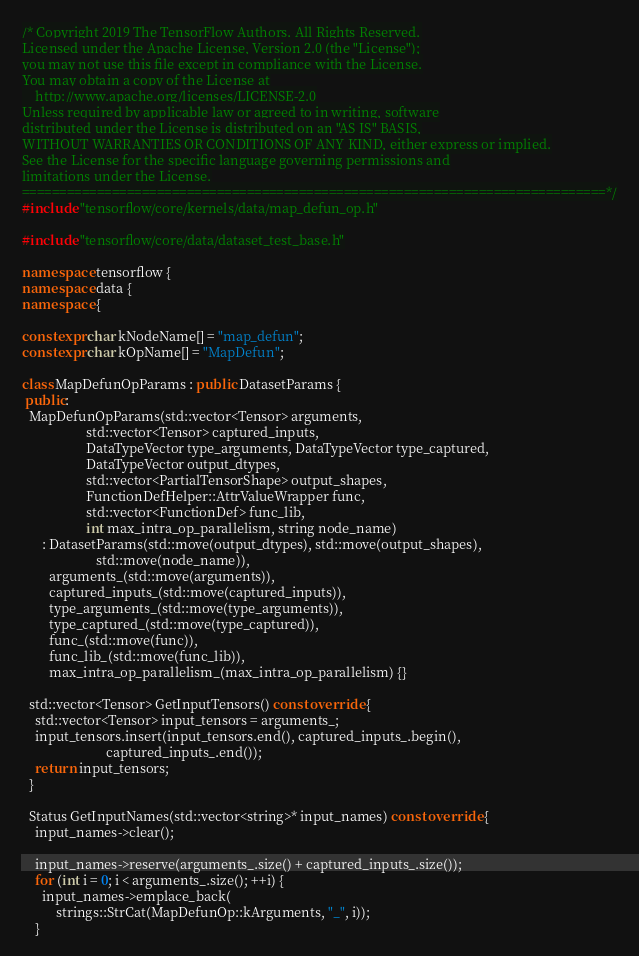Convert code to text. <code><loc_0><loc_0><loc_500><loc_500><_C++_>/* Copyright 2019 The TensorFlow Authors. All Rights Reserved.
Licensed under the Apache License, Version 2.0 (the "License");
you may not use this file except in compliance with the License.
You may obtain a copy of the License at
    http://www.apache.org/licenses/LICENSE-2.0
Unless required by applicable law or agreed to in writing, software
distributed under the License is distributed on an "AS IS" BASIS,
WITHOUT WARRANTIES OR CONDITIONS OF ANY KIND, either express or implied.
See the License for the specific language governing permissions and
limitations under the License.
==============================================================================*/
#include "tensorflow/core/kernels/data/map_defun_op.h"

#include "tensorflow/core/data/dataset_test_base.h"

namespace tensorflow {
namespace data {
namespace {

constexpr char kNodeName[] = "map_defun";
constexpr char kOpName[] = "MapDefun";

class MapDefunOpParams : public DatasetParams {
 public:
  MapDefunOpParams(std::vector<Tensor> arguments,
                   std::vector<Tensor> captured_inputs,
                   DataTypeVector type_arguments, DataTypeVector type_captured,
                   DataTypeVector output_dtypes,
                   std::vector<PartialTensorShape> output_shapes,
                   FunctionDefHelper::AttrValueWrapper func,
                   std::vector<FunctionDef> func_lib,
                   int max_intra_op_parallelism, string node_name)
      : DatasetParams(std::move(output_dtypes), std::move(output_shapes),
                      std::move(node_name)),
        arguments_(std::move(arguments)),
        captured_inputs_(std::move(captured_inputs)),
        type_arguments_(std::move(type_arguments)),
        type_captured_(std::move(type_captured)),
        func_(std::move(func)),
        func_lib_(std::move(func_lib)),
        max_intra_op_parallelism_(max_intra_op_parallelism) {}

  std::vector<Tensor> GetInputTensors() const override {
    std::vector<Tensor> input_tensors = arguments_;
    input_tensors.insert(input_tensors.end(), captured_inputs_.begin(),
                         captured_inputs_.end());
    return input_tensors;
  }

  Status GetInputNames(std::vector<string>* input_names) const override {
    input_names->clear();

    input_names->reserve(arguments_.size() + captured_inputs_.size());
    for (int i = 0; i < arguments_.size(); ++i) {
      input_names->emplace_back(
          strings::StrCat(MapDefunOp::kArguments, "_", i));
    }</code> 